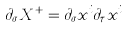Convert formula to latex. <formula><loc_0><loc_0><loc_500><loc_500>\partial _ { \sigma } X ^ { + } = \partial _ { \sigma } x ^ { i } \partial _ { \tau } x ^ { i }</formula> 